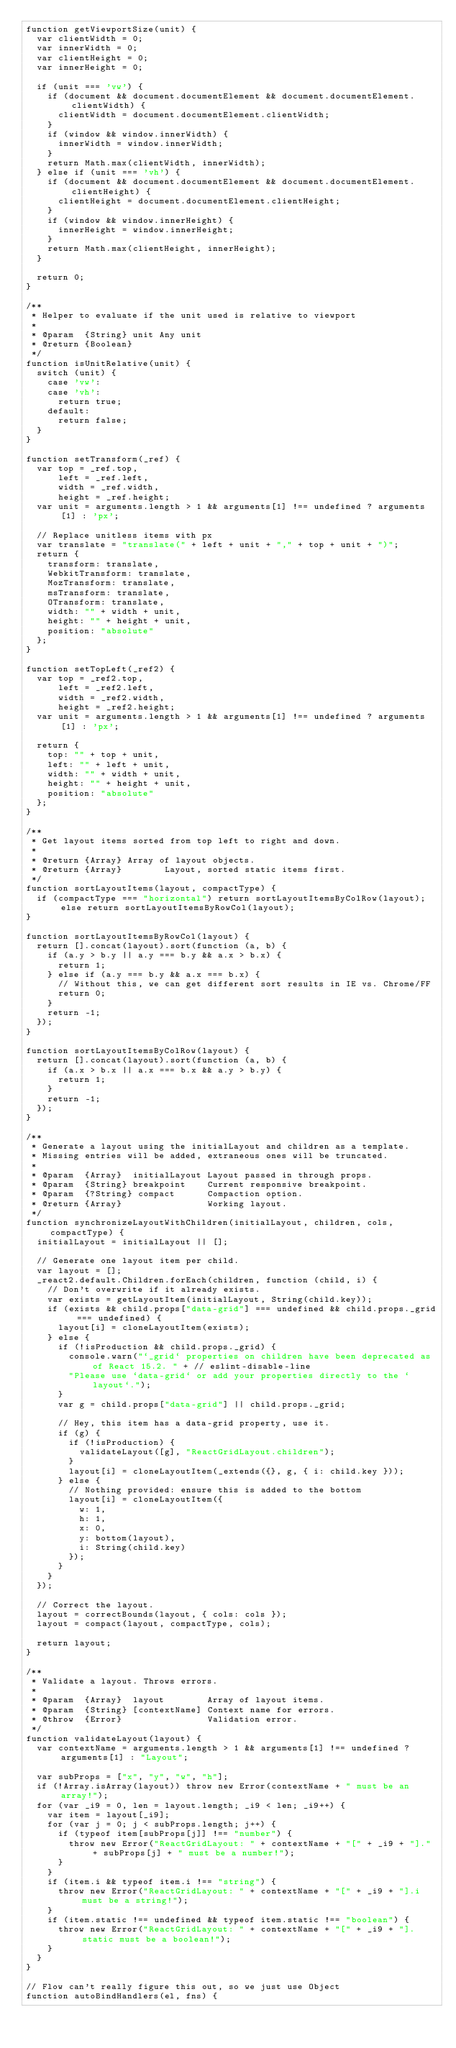Convert code to text. <code><loc_0><loc_0><loc_500><loc_500><_JavaScript_>function getViewportSize(unit) {
  var clientWidth = 0;
  var innerWidth = 0;
  var clientHeight = 0;
  var innerHeight = 0;

  if (unit === 'vw') {
    if (document && document.documentElement && document.documentElement.clientWidth) {
      clientWidth = document.documentElement.clientWidth;
    }
    if (window && window.innerWidth) {
      innerWidth = window.innerWidth;
    }
    return Math.max(clientWidth, innerWidth);
  } else if (unit === 'vh') {
    if (document && document.documentElement && document.documentElement.clientHeight) {
      clientHeight = document.documentElement.clientHeight;
    }
    if (window && window.innerHeight) {
      innerHeight = window.innerHeight;
    }
    return Math.max(clientHeight, innerHeight);
  }

  return 0;
}

/**
 * Helper to evaluate if the unit used is relative to viewport
 *
 * @param  {String} unit Any unit
 * @return {Boolean}
 */
function isUnitRelative(unit) {
  switch (unit) {
    case 'vw':
    case 'vh':
      return true;
    default:
      return false;
  }
}

function setTransform(_ref) {
  var top = _ref.top,
      left = _ref.left,
      width = _ref.width,
      height = _ref.height;
  var unit = arguments.length > 1 && arguments[1] !== undefined ? arguments[1] : 'px';

  // Replace unitless items with px
  var translate = "translate(" + left + unit + "," + top + unit + ")";
  return {
    transform: translate,
    WebkitTransform: translate,
    MozTransform: translate,
    msTransform: translate,
    OTransform: translate,
    width: "" + width + unit,
    height: "" + height + unit,
    position: "absolute"
  };
}

function setTopLeft(_ref2) {
  var top = _ref2.top,
      left = _ref2.left,
      width = _ref2.width,
      height = _ref2.height;
  var unit = arguments.length > 1 && arguments[1] !== undefined ? arguments[1] : 'px';

  return {
    top: "" + top + unit,
    left: "" + left + unit,
    width: "" + width + unit,
    height: "" + height + unit,
    position: "absolute"
  };
}

/**
 * Get layout items sorted from top left to right and down.
 *
 * @return {Array} Array of layout objects.
 * @return {Array}        Layout, sorted static items first.
 */
function sortLayoutItems(layout, compactType) {
  if (compactType === "horizontal") return sortLayoutItemsByColRow(layout);else return sortLayoutItemsByRowCol(layout);
}

function sortLayoutItemsByRowCol(layout) {
  return [].concat(layout).sort(function (a, b) {
    if (a.y > b.y || a.y === b.y && a.x > b.x) {
      return 1;
    } else if (a.y === b.y && a.x === b.x) {
      // Without this, we can get different sort results in IE vs. Chrome/FF
      return 0;
    }
    return -1;
  });
}

function sortLayoutItemsByColRow(layout) {
  return [].concat(layout).sort(function (a, b) {
    if (a.x > b.x || a.x === b.x && a.y > b.y) {
      return 1;
    }
    return -1;
  });
}

/**
 * Generate a layout using the initialLayout and children as a template.
 * Missing entries will be added, extraneous ones will be truncated.
 *
 * @param  {Array}  initialLayout Layout passed in through props.
 * @param  {String} breakpoint    Current responsive breakpoint.
 * @param  {?String} compact      Compaction option.
 * @return {Array}                Working layout.
 */
function synchronizeLayoutWithChildren(initialLayout, children, cols, compactType) {
  initialLayout = initialLayout || [];

  // Generate one layout item per child.
  var layout = [];
  _react2.default.Children.forEach(children, function (child, i) {
    // Don't overwrite if it already exists.
    var exists = getLayoutItem(initialLayout, String(child.key));
    if (exists && child.props["data-grid"] === undefined && child.props._grid === undefined) {
      layout[i] = cloneLayoutItem(exists);
    } else {
      if (!isProduction && child.props._grid) {
        console.warn("`_grid` properties on children have been deprecated as of React 15.2. " + // eslint-disable-line
        "Please use `data-grid` or add your properties directly to the `layout`.");
      }
      var g = child.props["data-grid"] || child.props._grid;

      // Hey, this item has a data-grid property, use it.
      if (g) {
        if (!isProduction) {
          validateLayout([g], "ReactGridLayout.children");
        }
        layout[i] = cloneLayoutItem(_extends({}, g, { i: child.key }));
      } else {
        // Nothing provided: ensure this is added to the bottom
        layout[i] = cloneLayoutItem({
          w: 1,
          h: 1,
          x: 0,
          y: bottom(layout),
          i: String(child.key)
        });
      }
    }
  });

  // Correct the layout.
  layout = correctBounds(layout, { cols: cols });
  layout = compact(layout, compactType, cols);

  return layout;
}

/**
 * Validate a layout. Throws errors.
 *
 * @param  {Array}  layout        Array of layout items.
 * @param  {String} [contextName] Context name for errors.
 * @throw  {Error}                Validation error.
 */
function validateLayout(layout) {
  var contextName = arguments.length > 1 && arguments[1] !== undefined ? arguments[1] : "Layout";

  var subProps = ["x", "y", "w", "h"];
  if (!Array.isArray(layout)) throw new Error(contextName + " must be an array!");
  for (var _i9 = 0, len = layout.length; _i9 < len; _i9++) {
    var item = layout[_i9];
    for (var j = 0; j < subProps.length; j++) {
      if (typeof item[subProps[j]] !== "number") {
        throw new Error("ReactGridLayout: " + contextName + "[" + _i9 + "]." + subProps[j] + " must be a number!");
      }
    }
    if (item.i && typeof item.i !== "string") {
      throw new Error("ReactGridLayout: " + contextName + "[" + _i9 + "].i must be a string!");
    }
    if (item.static !== undefined && typeof item.static !== "boolean") {
      throw new Error("ReactGridLayout: " + contextName + "[" + _i9 + "].static must be a boolean!");
    }
  }
}

// Flow can't really figure this out, so we just use Object
function autoBindHandlers(el, fns) {</code> 